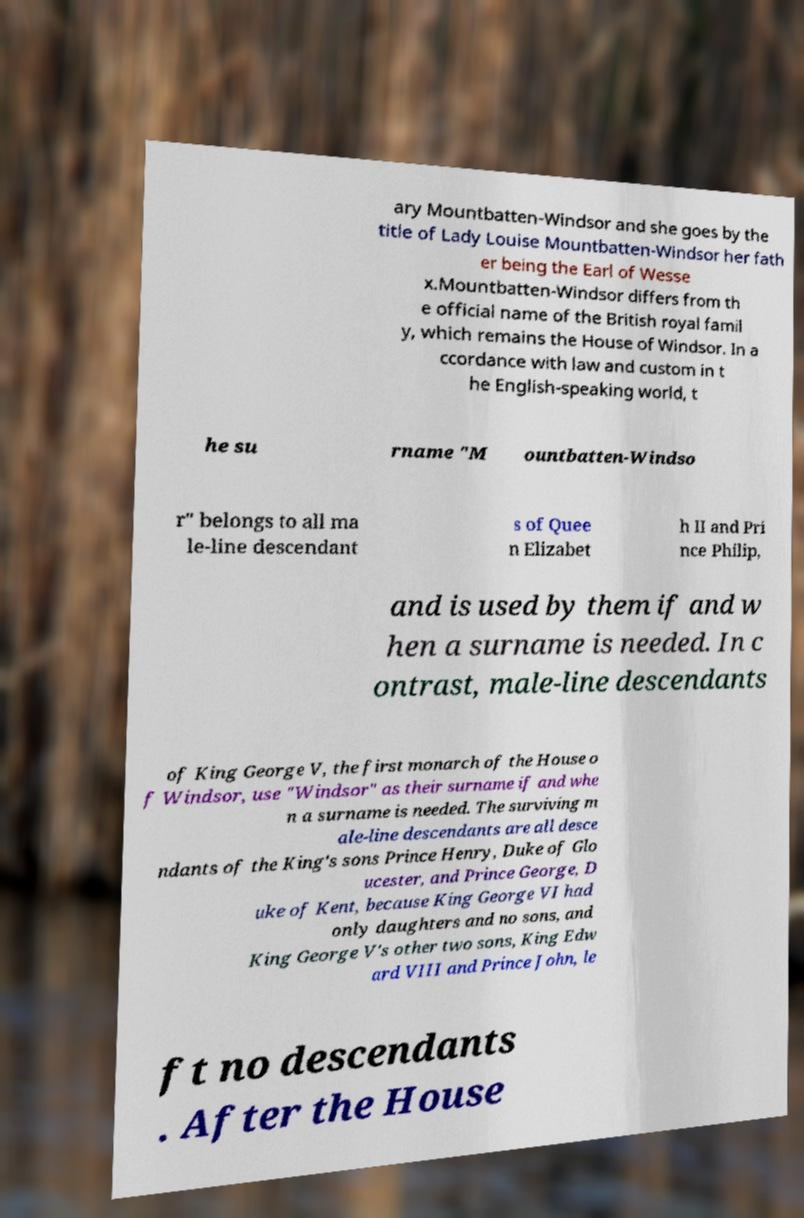For documentation purposes, I need the text within this image transcribed. Could you provide that? ary Mountbatten-Windsor and she goes by the title of Lady Louise Mountbatten-Windsor her fath er being the Earl of Wesse x.Mountbatten-Windsor differs from th e official name of the British royal famil y, which remains the House of Windsor. In a ccordance with law and custom in t he English-speaking world, t he su rname "M ountbatten-Windso r" belongs to all ma le-line descendant s of Quee n Elizabet h II and Pri nce Philip, and is used by them if and w hen a surname is needed. In c ontrast, male-line descendants of King George V, the first monarch of the House o f Windsor, use "Windsor" as their surname if and whe n a surname is needed. The surviving m ale-line descendants are all desce ndants of the King's sons Prince Henry, Duke of Glo ucester, and Prince George, D uke of Kent, because King George VI had only daughters and no sons, and King George V's other two sons, King Edw ard VIII and Prince John, le ft no descendants . After the House 